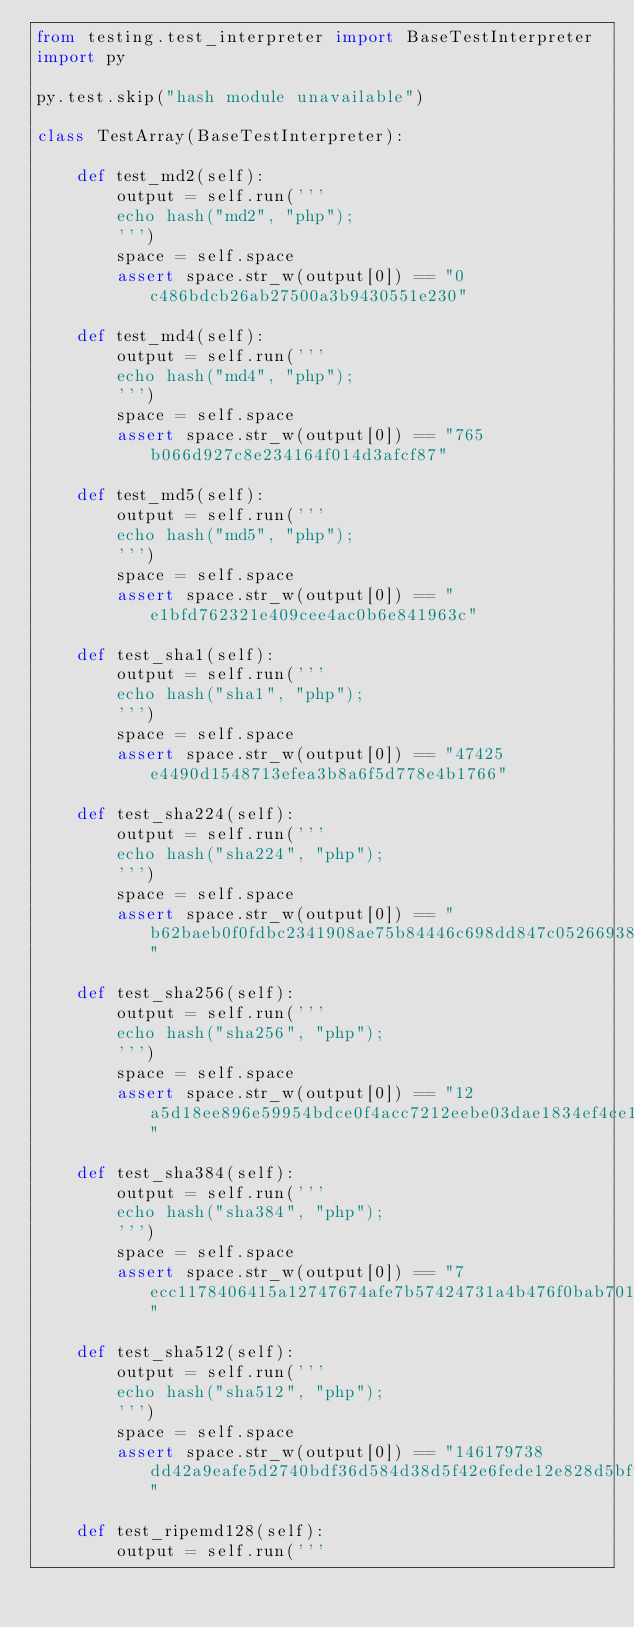Convert code to text. <code><loc_0><loc_0><loc_500><loc_500><_Python_>from testing.test_interpreter import BaseTestInterpreter
import py

py.test.skip("hash module unavailable")

class TestArray(BaseTestInterpreter):

    def test_md2(self):
        output = self.run('''
        echo hash("md2", "php");
        ''')
        space = self.space
        assert space.str_w(output[0]) == "0c486bdcb26ab27500a3b9430551e230"

    def test_md4(self):
        output = self.run('''
        echo hash("md4", "php");
        ''')
        space = self.space
        assert space.str_w(output[0]) == "765b066d927c8e234164f014d3afcf87"

    def test_md5(self):
        output = self.run('''
        echo hash("md5", "php");
        ''')
        space = self.space
        assert space.str_w(output[0]) == "e1bfd762321e409cee4ac0b6e841963c"

    def test_sha1(self):
        output = self.run('''
        echo hash("sha1", "php");
        ''')
        space = self.space
        assert space.str_w(output[0]) == "47425e4490d1548713efea3b8a6f5d778e4b1766"

    def test_sha224(self):
        output = self.run('''
        echo hash("sha224", "php");
        ''')
        space = self.space
        assert space.str_w(output[0]) == "b62baeb0f0fdbc2341908ae75b84446c698dd847c0526693869605d2"

    def test_sha256(self):
        output = self.run('''
        echo hash("sha256", "php");
        ''')
        space = self.space
        assert space.str_w(output[0]) == "12a5d18ee896e59954bdce0f4acc7212eebe03dae1834ef4ce160ac5afa5c4a8"

    def test_sha384(self):
        output = self.run('''
        echo hash("sha384", "php");
        ''')
        space = self.space
        assert space.str_w(output[0]) == "7ecc1178406415a12747674afe7b57424731a4b476f0bab701ebbb15d31233bc1434d83c283a1cc40bc479e1e63ca046"

    def test_sha512(self):
        output = self.run('''
        echo hash("sha512", "php");
        ''')
        space = self.space
        assert space.str_w(output[0]) == "146179738dd42a9eafe5d2740bdf36d584d38d5f42e6fede12e828d5bf97a57a180bfa90c157c173e09a5c71876695807c06d39985c4ddf7b7d9800cb84ab9d7"

    def test_ripemd128(self):
        output = self.run('''</code> 